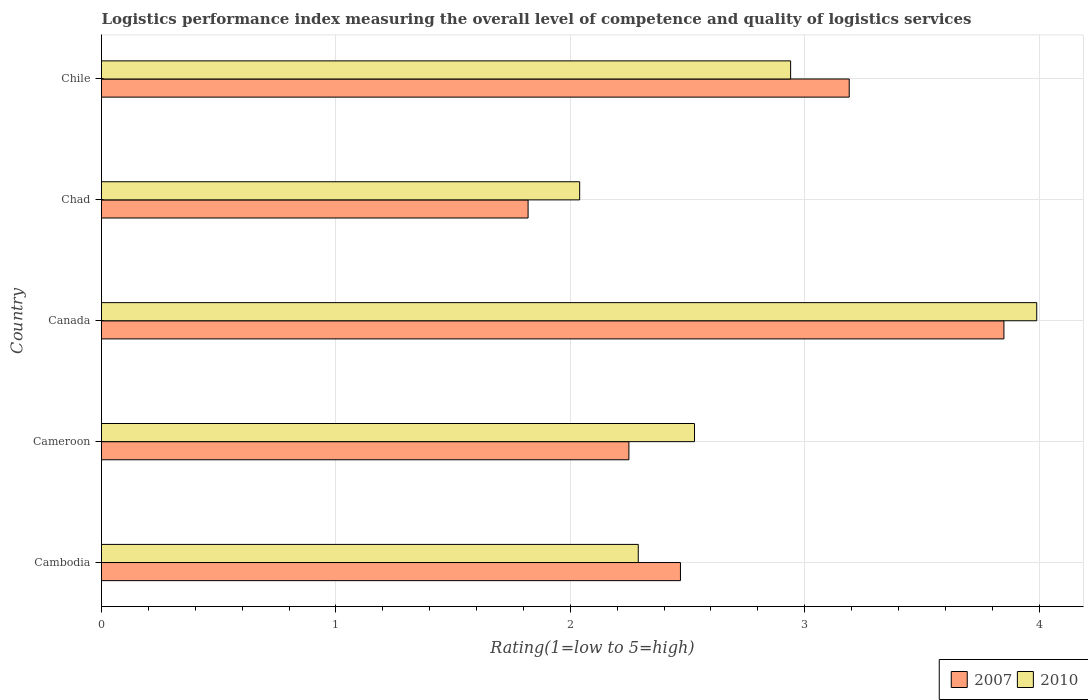How many different coloured bars are there?
Ensure brevity in your answer.  2. Are the number of bars per tick equal to the number of legend labels?
Offer a terse response. Yes. Are the number of bars on each tick of the Y-axis equal?
Make the answer very short. Yes. How many bars are there on the 2nd tick from the top?
Your answer should be compact. 2. In how many cases, is the number of bars for a given country not equal to the number of legend labels?
Ensure brevity in your answer.  0. What is the Logistic performance index in 2010 in Canada?
Ensure brevity in your answer.  3.99. Across all countries, what is the maximum Logistic performance index in 2007?
Keep it short and to the point. 3.85. Across all countries, what is the minimum Logistic performance index in 2007?
Offer a terse response. 1.82. In which country was the Logistic performance index in 2007 minimum?
Give a very brief answer. Chad. What is the total Logistic performance index in 2007 in the graph?
Your answer should be very brief. 13.58. What is the difference between the Logistic performance index in 2010 in Cambodia and the Logistic performance index in 2007 in Cameroon?
Your response must be concise. 0.04. What is the average Logistic performance index in 2010 per country?
Provide a short and direct response. 2.76. What is the difference between the Logistic performance index in 2007 and Logistic performance index in 2010 in Canada?
Keep it short and to the point. -0.14. What is the ratio of the Logistic performance index in 2007 in Cameroon to that in Chad?
Offer a terse response. 1.24. What is the difference between the highest and the second highest Logistic performance index in 2007?
Your answer should be very brief. 0.66. What is the difference between the highest and the lowest Logistic performance index in 2007?
Make the answer very short. 2.03. Is the sum of the Logistic performance index in 2010 in Cambodia and Canada greater than the maximum Logistic performance index in 2007 across all countries?
Give a very brief answer. Yes. What does the 2nd bar from the top in Cameroon represents?
Offer a very short reply. 2007. What does the 2nd bar from the bottom in Chile represents?
Provide a short and direct response. 2010. How many bars are there?
Offer a terse response. 10. Are all the bars in the graph horizontal?
Make the answer very short. Yes. How many countries are there in the graph?
Offer a terse response. 5. What is the difference between two consecutive major ticks on the X-axis?
Offer a terse response. 1. Are the values on the major ticks of X-axis written in scientific E-notation?
Make the answer very short. No. What is the title of the graph?
Make the answer very short. Logistics performance index measuring the overall level of competence and quality of logistics services. Does "2011" appear as one of the legend labels in the graph?
Make the answer very short. No. What is the label or title of the X-axis?
Provide a short and direct response. Rating(1=low to 5=high). What is the Rating(1=low to 5=high) of 2007 in Cambodia?
Give a very brief answer. 2.47. What is the Rating(1=low to 5=high) in 2010 in Cambodia?
Offer a terse response. 2.29. What is the Rating(1=low to 5=high) in 2007 in Cameroon?
Offer a terse response. 2.25. What is the Rating(1=low to 5=high) of 2010 in Cameroon?
Your response must be concise. 2.53. What is the Rating(1=low to 5=high) in 2007 in Canada?
Keep it short and to the point. 3.85. What is the Rating(1=low to 5=high) of 2010 in Canada?
Give a very brief answer. 3.99. What is the Rating(1=low to 5=high) of 2007 in Chad?
Your answer should be compact. 1.82. What is the Rating(1=low to 5=high) of 2010 in Chad?
Your answer should be very brief. 2.04. What is the Rating(1=low to 5=high) of 2007 in Chile?
Provide a short and direct response. 3.19. What is the Rating(1=low to 5=high) in 2010 in Chile?
Offer a very short reply. 2.94. Across all countries, what is the maximum Rating(1=low to 5=high) of 2007?
Your response must be concise. 3.85. Across all countries, what is the maximum Rating(1=low to 5=high) in 2010?
Your answer should be compact. 3.99. Across all countries, what is the minimum Rating(1=low to 5=high) of 2007?
Your response must be concise. 1.82. Across all countries, what is the minimum Rating(1=low to 5=high) in 2010?
Provide a short and direct response. 2.04. What is the total Rating(1=low to 5=high) in 2007 in the graph?
Your answer should be very brief. 13.58. What is the total Rating(1=low to 5=high) of 2010 in the graph?
Ensure brevity in your answer.  13.79. What is the difference between the Rating(1=low to 5=high) in 2007 in Cambodia and that in Cameroon?
Ensure brevity in your answer.  0.22. What is the difference between the Rating(1=low to 5=high) of 2010 in Cambodia and that in Cameroon?
Your answer should be very brief. -0.24. What is the difference between the Rating(1=low to 5=high) of 2007 in Cambodia and that in Canada?
Offer a terse response. -1.38. What is the difference between the Rating(1=low to 5=high) of 2010 in Cambodia and that in Canada?
Offer a very short reply. -1.7. What is the difference between the Rating(1=low to 5=high) in 2007 in Cambodia and that in Chad?
Provide a succinct answer. 0.65. What is the difference between the Rating(1=low to 5=high) of 2010 in Cambodia and that in Chad?
Keep it short and to the point. 0.25. What is the difference between the Rating(1=low to 5=high) in 2007 in Cambodia and that in Chile?
Keep it short and to the point. -0.72. What is the difference between the Rating(1=low to 5=high) in 2010 in Cambodia and that in Chile?
Make the answer very short. -0.65. What is the difference between the Rating(1=low to 5=high) in 2007 in Cameroon and that in Canada?
Keep it short and to the point. -1.6. What is the difference between the Rating(1=low to 5=high) in 2010 in Cameroon and that in Canada?
Ensure brevity in your answer.  -1.46. What is the difference between the Rating(1=low to 5=high) in 2007 in Cameroon and that in Chad?
Your answer should be compact. 0.43. What is the difference between the Rating(1=low to 5=high) in 2010 in Cameroon and that in Chad?
Provide a short and direct response. 0.49. What is the difference between the Rating(1=low to 5=high) in 2007 in Cameroon and that in Chile?
Provide a succinct answer. -0.94. What is the difference between the Rating(1=low to 5=high) of 2010 in Cameroon and that in Chile?
Keep it short and to the point. -0.41. What is the difference between the Rating(1=low to 5=high) of 2007 in Canada and that in Chad?
Your response must be concise. 2.03. What is the difference between the Rating(1=low to 5=high) in 2010 in Canada and that in Chad?
Offer a very short reply. 1.95. What is the difference between the Rating(1=low to 5=high) in 2007 in Canada and that in Chile?
Make the answer very short. 0.66. What is the difference between the Rating(1=low to 5=high) of 2007 in Chad and that in Chile?
Offer a terse response. -1.37. What is the difference between the Rating(1=low to 5=high) of 2010 in Chad and that in Chile?
Your response must be concise. -0.9. What is the difference between the Rating(1=low to 5=high) in 2007 in Cambodia and the Rating(1=low to 5=high) in 2010 in Cameroon?
Make the answer very short. -0.06. What is the difference between the Rating(1=low to 5=high) in 2007 in Cambodia and the Rating(1=low to 5=high) in 2010 in Canada?
Give a very brief answer. -1.52. What is the difference between the Rating(1=low to 5=high) in 2007 in Cambodia and the Rating(1=low to 5=high) in 2010 in Chad?
Keep it short and to the point. 0.43. What is the difference between the Rating(1=low to 5=high) in 2007 in Cambodia and the Rating(1=low to 5=high) in 2010 in Chile?
Provide a short and direct response. -0.47. What is the difference between the Rating(1=low to 5=high) in 2007 in Cameroon and the Rating(1=low to 5=high) in 2010 in Canada?
Give a very brief answer. -1.74. What is the difference between the Rating(1=low to 5=high) in 2007 in Cameroon and the Rating(1=low to 5=high) in 2010 in Chad?
Make the answer very short. 0.21. What is the difference between the Rating(1=low to 5=high) of 2007 in Cameroon and the Rating(1=low to 5=high) of 2010 in Chile?
Make the answer very short. -0.69. What is the difference between the Rating(1=low to 5=high) in 2007 in Canada and the Rating(1=low to 5=high) in 2010 in Chad?
Your answer should be very brief. 1.81. What is the difference between the Rating(1=low to 5=high) of 2007 in Canada and the Rating(1=low to 5=high) of 2010 in Chile?
Offer a very short reply. 0.91. What is the difference between the Rating(1=low to 5=high) in 2007 in Chad and the Rating(1=low to 5=high) in 2010 in Chile?
Provide a succinct answer. -1.12. What is the average Rating(1=low to 5=high) of 2007 per country?
Make the answer very short. 2.72. What is the average Rating(1=low to 5=high) of 2010 per country?
Your answer should be very brief. 2.76. What is the difference between the Rating(1=low to 5=high) of 2007 and Rating(1=low to 5=high) of 2010 in Cambodia?
Keep it short and to the point. 0.18. What is the difference between the Rating(1=low to 5=high) in 2007 and Rating(1=low to 5=high) in 2010 in Cameroon?
Offer a terse response. -0.28. What is the difference between the Rating(1=low to 5=high) in 2007 and Rating(1=low to 5=high) in 2010 in Canada?
Make the answer very short. -0.14. What is the difference between the Rating(1=low to 5=high) of 2007 and Rating(1=low to 5=high) of 2010 in Chad?
Your answer should be compact. -0.22. What is the ratio of the Rating(1=low to 5=high) in 2007 in Cambodia to that in Cameroon?
Your answer should be very brief. 1.1. What is the ratio of the Rating(1=low to 5=high) of 2010 in Cambodia to that in Cameroon?
Keep it short and to the point. 0.91. What is the ratio of the Rating(1=low to 5=high) in 2007 in Cambodia to that in Canada?
Your answer should be very brief. 0.64. What is the ratio of the Rating(1=low to 5=high) of 2010 in Cambodia to that in Canada?
Offer a terse response. 0.57. What is the ratio of the Rating(1=low to 5=high) in 2007 in Cambodia to that in Chad?
Your response must be concise. 1.36. What is the ratio of the Rating(1=low to 5=high) of 2010 in Cambodia to that in Chad?
Ensure brevity in your answer.  1.12. What is the ratio of the Rating(1=low to 5=high) of 2007 in Cambodia to that in Chile?
Provide a succinct answer. 0.77. What is the ratio of the Rating(1=low to 5=high) in 2010 in Cambodia to that in Chile?
Your response must be concise. 0.78. What is the ratio of the Rating(1=low to 5=high) in 2007 in Cameroon to that in Canada?
Offer a very short reply. 0.58. What is the ratio of the Rating(1=low to 5=high) in 2010 in Cameroon to that in Canada?
Give a very brief answer. 0.63. What is the ratio of the Rating(1=low to 5=high) of 2007 in Cameroon to that in Chad?
Ensure brevity in your answer.  1.24. What is the ratio of the Rating(1=low to 5=high) in 2010 in Cameroon to that in Chad?
Your response must be concise. 1.24. What is the ratio of the Rating(1=low to 5=high) of 2007 in Cameroon to that in Chile?
Keep it short and to the point. 0.71. What is the ratio of the Rating(1=low to 5=high) of 2010 in Cameroon to that in Chile?
Make the answer very short. 0.86. What is the ratio of the Rating(1=low to 5=high) in 2007 in Canada to that in Chad?
Offer a terse response. 2.12. What is the ratio of the Rating(1=low to 5=high) of 2010 in Canada to that in Chad?
Provide a succinct answer. 1.96. What is the ratio of the Rating(1=low to 5=high) in 2007 in Canada to that in Chile?
Offer a very short reply. 1.21. What is the ratio of the Rating(1=low to 5=high) of 2010 in Canada to that in Chile?
Provide a succinct answer. 1.36. What is the ratio of the Rating(1=low to 5=high) in 2007 in Chad to that in Chile?
Offer a very short reply. 0.57. What is the ratio of the Rating(1=low to 5=high) in 2010 in Chad to that in Chile?
Make the answer very short. 0.69. What is the difference between the highest and the second highest Rating(1=low to 5=high) in 2007?
Give a very brief answer. 0.66. What is the difference between the highest and the second highest Rating(1=low to 5=high) of 2010?
Your answer should be compact. 1.05. What is the difference between the highest and the lowest Rating(1=low to 5=high) in 2007?
Ensure brevity in your answer.  2.03. What is the difference between the highest and the lowest Rating(1=low to 5=high) of 2010?
Provide a short and direct response. 1.95. 